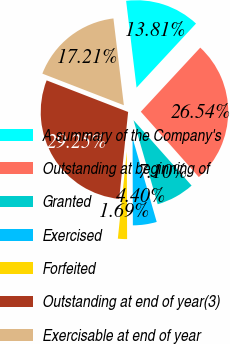Convert chart to OTSL. <chart><loc_0><loc_0><loc_500><loc_500><pie_chart><fcel>A summary of the Company's<fcel>Outstanding at beginning of<fcel>Granted<fcel>Exercised<fcel>Forfeited<fcel>Outstanding at end of year(3)<fcel>Exercisable at end of year<nl><fcel>13.81%<fcel>26.54%<fcel>7.1%<fcel>4.4%<fcel>1.69%<fcel>29.25%<fcel>17.21%<nl></chart> 